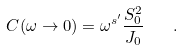Convert formula to latex. <formula><loc_0><loc_0><loc_500><loc_500>C ( \omega \to 0 ) = \omega ^ { s ^ { \prime } } \frac { S _ { 0 } ^ { 2 } } { J _ { 0 } } \quad .</formula> 